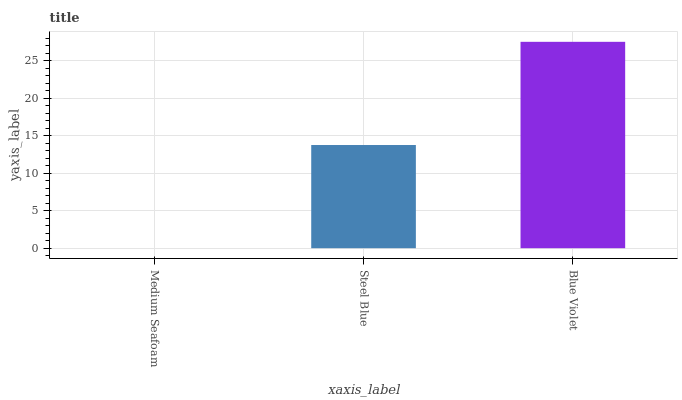Is Medium Seafoam the minimum?
Answer yes or no. Yes. Is Blue Violet the maximum?
Answer yes or no. Yes. Is Steel Blue the minimum?
Answer yes or no. No. Is Steel Blue the maximum?
Answer yes or no. No. Is Steel Blue greater than Medium Seafoam?
Answer yes or no. Yes. Is Medium Seafoam less than Steel Blue?
Answer yes or no. Yes. Is Medium Seafoam greater than Steel Blue?
Answer yes or no. No. Is Steel Blue less than Medium Seafoam?
Answer yes or no. No. Is Steel Blue the high median?
Answer yes or no. Yes. Is Steel Blue the low median?
Answer yes or no. Yes. Is Blue Violet the high median?
Answer yes or no. No. Is Medium Seafoam the low median?
Answer yes or no. No. 